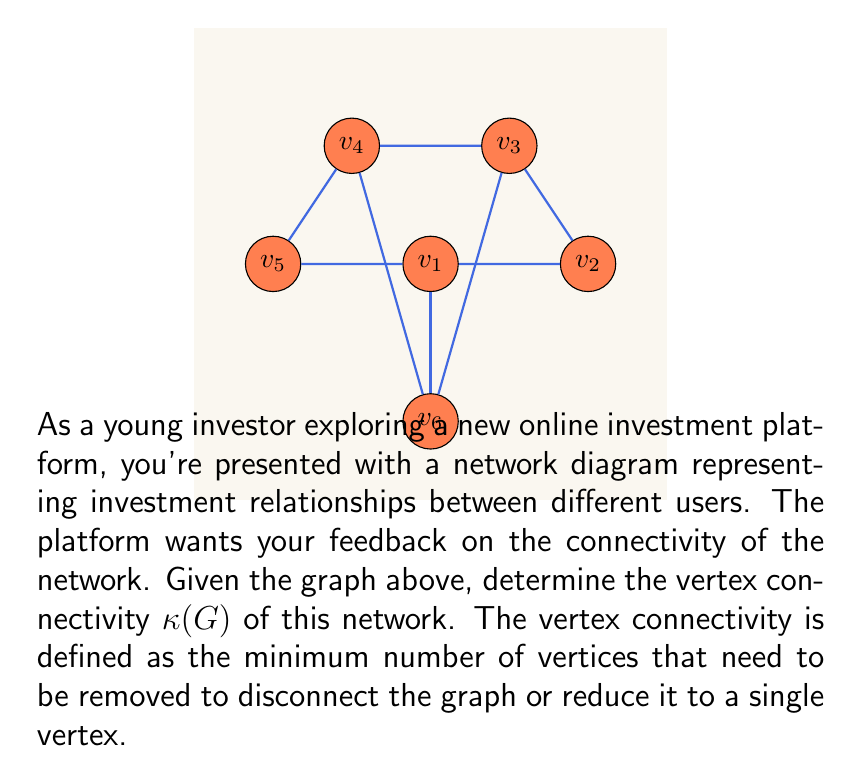Solve this math problem. To determine the vertex connectivity $\kappa(G)$ of the given graph, we need to find the minimum number of vertices that, when removed, will disconnect the graph or reduce it to a single vertex. Let's approach this step-by-step:

1) First, observe that the graph is connected and has no cut vertices (vertices that, when removed, would disconnect the graph).

2) We need to consider sets of vertices that, when removed, would disconnect the graph:

   a) Removing any single vertex doesn't disconnect the graph, so $\kappa(G) > 1$.
   
   b) Let's consider pairs of vertices:
      - Removing $v_1$ and $v_6$ disconnects $v_5$ from the rest of the graph.
      - Removing $v_2$ and $v_5$ disconnects $v_1$ from the rest of the graph.
      - Removing $v_3$ and $v_4$ disconnects $v_5$ from the rest of the graph.

3) We've found that removing two vertices can disconnect the graph, and we can't disconnect the graph by removing just one vertex.

4) Therefore, the vertex connectivity $\kappa(G)$ is 2.

This means that the investment network is relatively robust, as it requires removing at least two users to disconnect the network. However, there are multiple ways to disconnect the network by removing two users, which could be a point of consideration for improving the platform's resilience.
Answer: $\kappa(G) = 2$ 